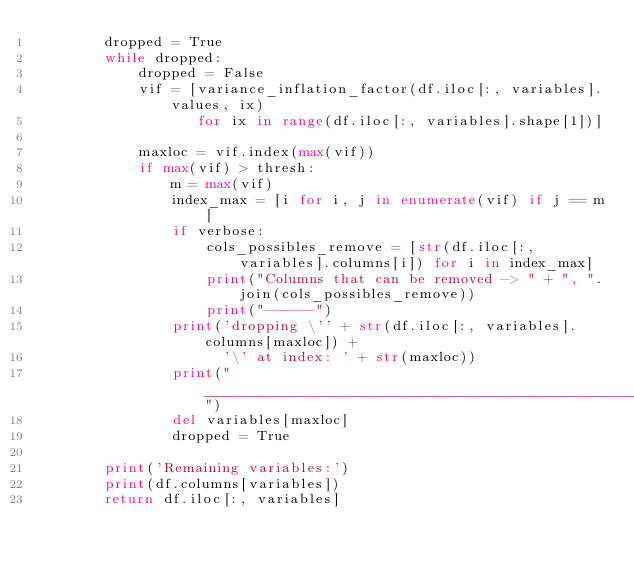<code> <loc_0><loc_0><loc_500><loc_500><_Python_>        dropped = True
        while dropped:
            dropped = False
            vif = [variance_inflation_factor(df.iloc[:, variables].values, ix)
                   for ix in range(df.iloc[:, variables].shape[1])]

            maxloc = vif.index(max(vif))
            if max(vif) > thresh:
                m = max(vif)
                index_max = [i for i, j in enumerate(vif) if j == m]
                if verbose:
                    cols_possibles_remove = [str(df.iloc[:, variables].columns[i]) for i in index_max]
                    print("Columns that can be removed -> " + ", ".join(cols_possibles_remove))
                    print("------")
                print('dropping \'' + str(df.iloc[:, variables].columns[maxloc]) +
                      '\' at index: ' + str(maxloc))
                print("_____________________________________________________________")
                del variables[maxloc]
                dropped = True

        print('Remaining variables:')
        print(df.columns[variables])
        return df.iloc[:, variables]</code> 